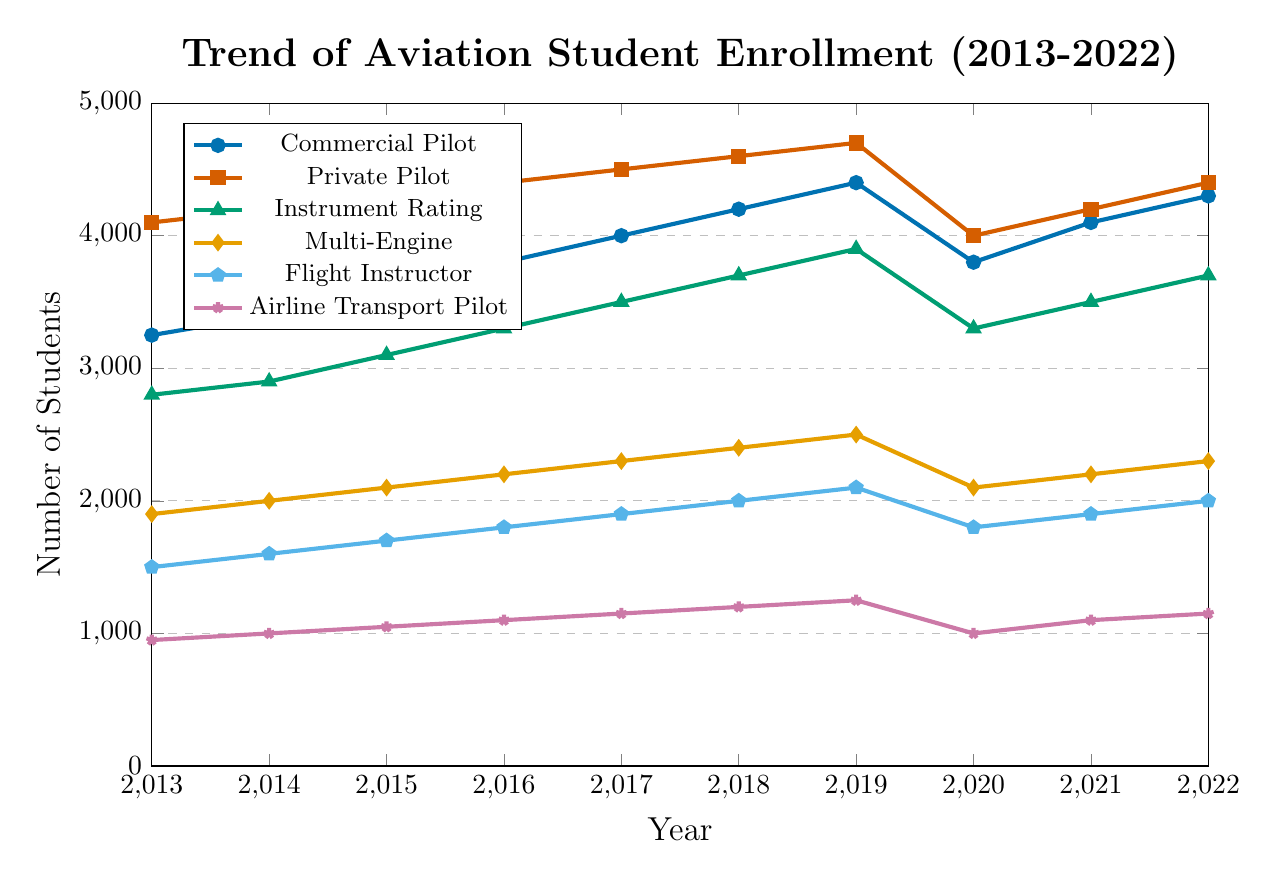What is the trend of Private Pilot enrollments over the past decade? By observing the blue line with square markers, it can be seen that the number of Private Pilot enrollments has been gradually increasing from 2013 to 2019, dropped sharply in 2020, and then slightly increased again from 2021 to 2022.
Answer: Increasing with a slight dip in 2020 How did enrollment numbers for Commercial Pilot compare from 2019 to 2020? By looking at the data points for Commercial Pilot enrollments on the figure, it's clear that the number dropped from 4400 in 2019 to 3800 in 2020.
Answer: Dropped Which program type saw the highest enrollment in 2019? The figure shows that among all lines representing different programs, the line corresponding to the Private Pilot had the highest value, specifically 4700 in 2019.
Answer: Private Pilot What were the enrollment trends for all programs during the year 2020? Observing all lines for 2020, it is evident that all programs saw a dip in enrollments compared to the previous year 2019, reflecting a downward trend.
Answer: Decrease in all programs Which program type shows the least fluctuation over the decade? The figure shows that the Airline Transport Pilot line has relatively lesser slopes and changes compared to other programs, indicating it had the least fluctuation over the decade.
Answer: Airline Transport Pilot By how much did Multi-Engine enrollments increase from 2013 to 2019? In the figure, the 2013 value for Multi-Engine enrollments is 1900, and the 2019 value is 2500. Finding the difference, we get 2500 - 1900 = 600.
Answer: 600 Which year had the highest total enrollment across all programs? Summing the enrollments for each year, we find the highest total occurred in 2019 (Commercial Pilot: 4400 + Private Pilot: 4700 + Instrument Rating: 3900 + Multi-Engine: 2500 + Flight Instructor: 2100 + Airline Transport Pilot: 1250). Total = 18850, the highest year compared to others.
Answer: 2019 What was the average yearly enrollment for the Flight Instructor program over the ten years? The figure's values for Flight Instructor are summed (1500 + 1600 + 1700 + 1800 + 1900 + 2000 + 2100 + 1800 + 1900 + 2000 = 18300) and then divided by 10 to get the average: 18300/10 = 1830.
Answer: 1830 What was the difference in enrollment between the highest and lowest programs in 2022? From the figure in 2022, the highest enrollment is for Private Pilot (4400) and the lowest is for Airline Transport Pilot (1150). The difference is 4400 - 1150 = 3250.
Answer: 3250 Did any programs recover their 2019 enrollment numbers by 2022? By observing the figure, it's clear that none of the programs fully recovered their 2019 enrollment numbers by 2022; though there were increases in some, none matched the 2019 peaks except for Flight Instructor which returned to 2000.
Answer: No 